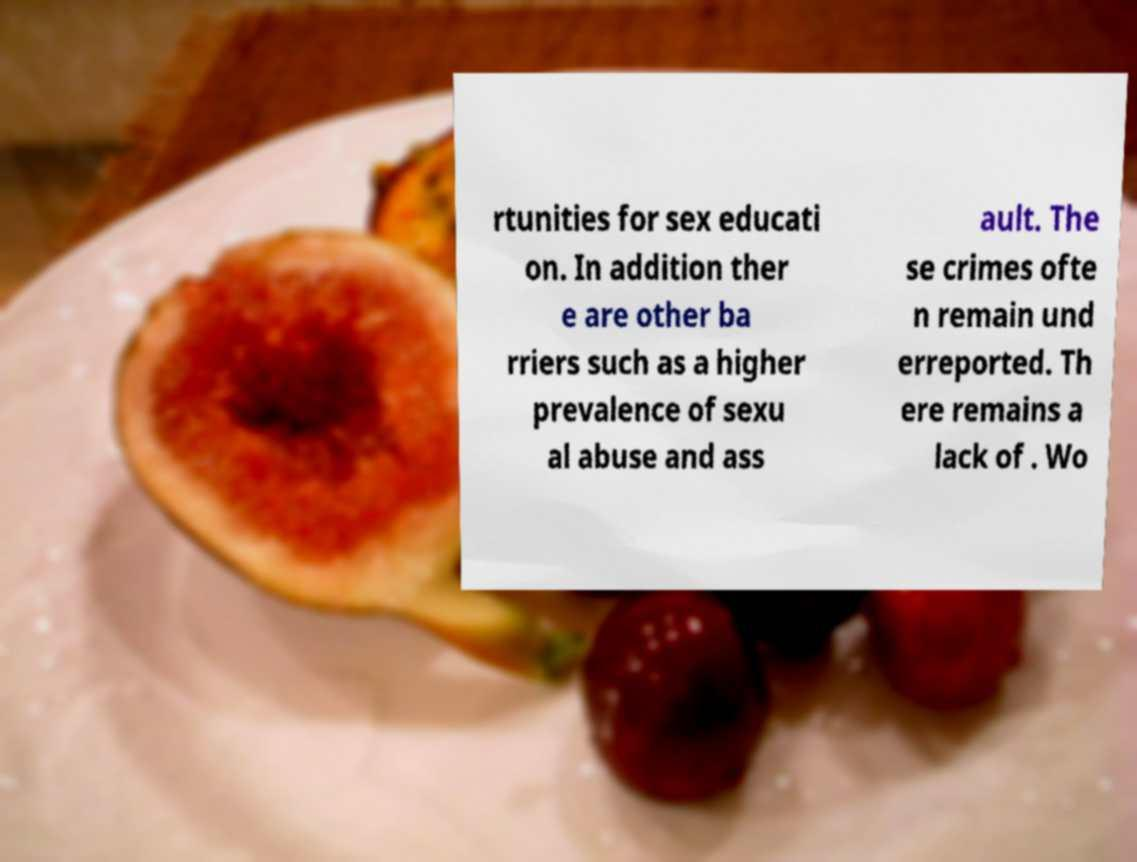Can you accurately transcribe the text from the provided image for me? rtunities for sex educati on. In addition ther e are other ba rriers such as a higher prevalence of sexu al abuse and ass ault. The se crimes ofte n remain und erreported. Th ere remains a lack of . Wo 